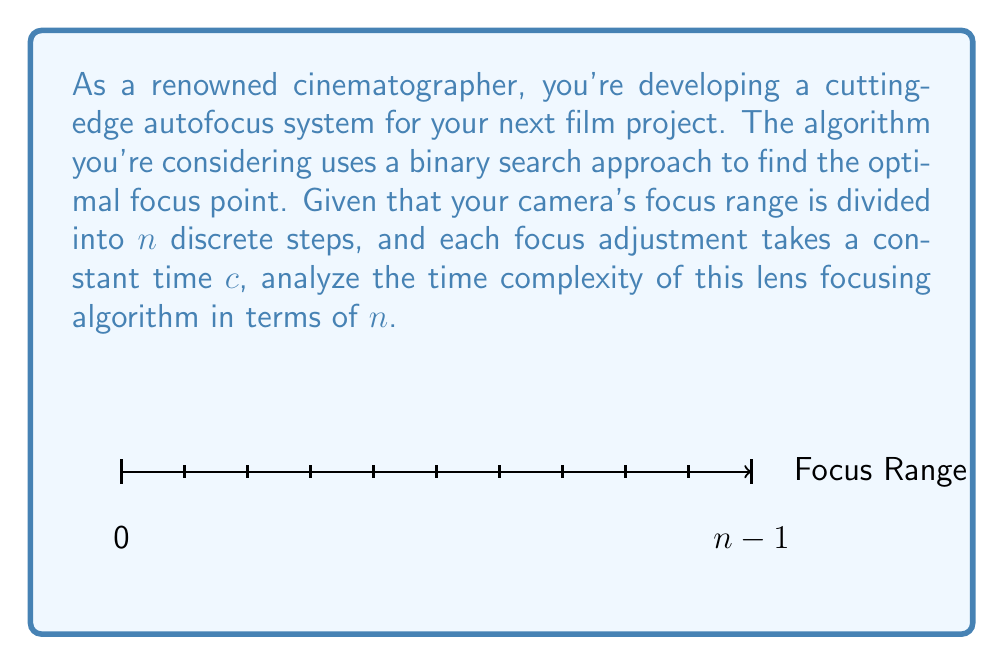Show me your answer to this math problem. Let's analyze the time complexity of this lens focusing algorithm step by step:

1) The binary search algorithm works by repeatedly dividing the search interval in half.

2) In each iteration:
   - The algorithm checks the middle point of the current interval.
   - It then decides whether to continue searching in the left or right half.

3) The number of iterations required is determined by how many times we can divide $n$ by 2 until we reach 1. This is mathematically expressed as $\log_2(n)$.

4) In each iteration:
   - Finding the middle point takes constant time.
   - Adjusting the focus to that point takes constant time $c$.
   - Evaluating the focus quality takes constant time.

5) Therefore, each iteration takes $O(1)$ time.

6) The total number of iterations is $\log_2(n)$, and each iteration takes constant time, so the total time is proportional to $\log_2(n)$.

7) In Big O notation, we typically omit constant factors and the base of the logarithm (since $\log_a(n) = \frac{\log_b(n)}{\log_b(a)}$ for any bases $a$ and $b$, which only differs by a constant factor).

Thus, the time complexity of this lens focusing algorithm is $O(\log n)$.
Answer: $O(\log n)$ 